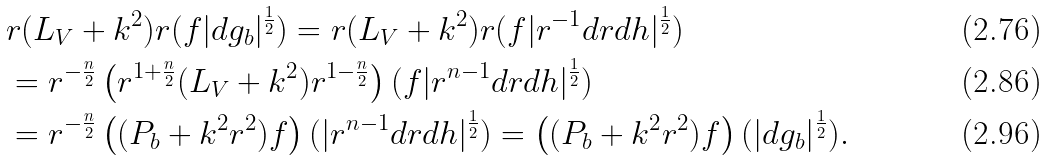Convert formula to latex. <formula><loc_0><loc_0><loc_500><loc_500>& r ( \L L _ { V } + k ^ { 2 } ) r ( f | d g _ { b } | ^ { \frac { 1 } { 2 } } ) = r ( \L L _ { V } + k ^ { 2 } ) r ( f | r ^ { - 1 } d r d h | ^ { \frac { 1 } { 2 } } ) \\ & = r ^ { - \frac { n } { 2 } } \left ( r ^ { 1 + \frac { n } { 2 } } ( \L L _ { V } + k ^ { 2 } ) r ^ { 1 - \frac { n } { 2 } } \right ) ( f | r ^ { n - 1 } d r d h | ^ { \frac { 1 } { 2 } } ) \\ & = r ^ { - \frac { n } { 2 } } \left ( ( P _ { b } + k ^ { 2 } r ^ { 2 } ) f \right ) ( | r ^ { n - 1 } d r d h | ^ { \frac { 1 } { 2 } } ) = \left ( ( P _ { b } + k ^ { 2 } r ^ { 2 } ) f \right ) ( | d g _ { b } | ^ { \frac { 1 } { 2 } } ) .</formula> 